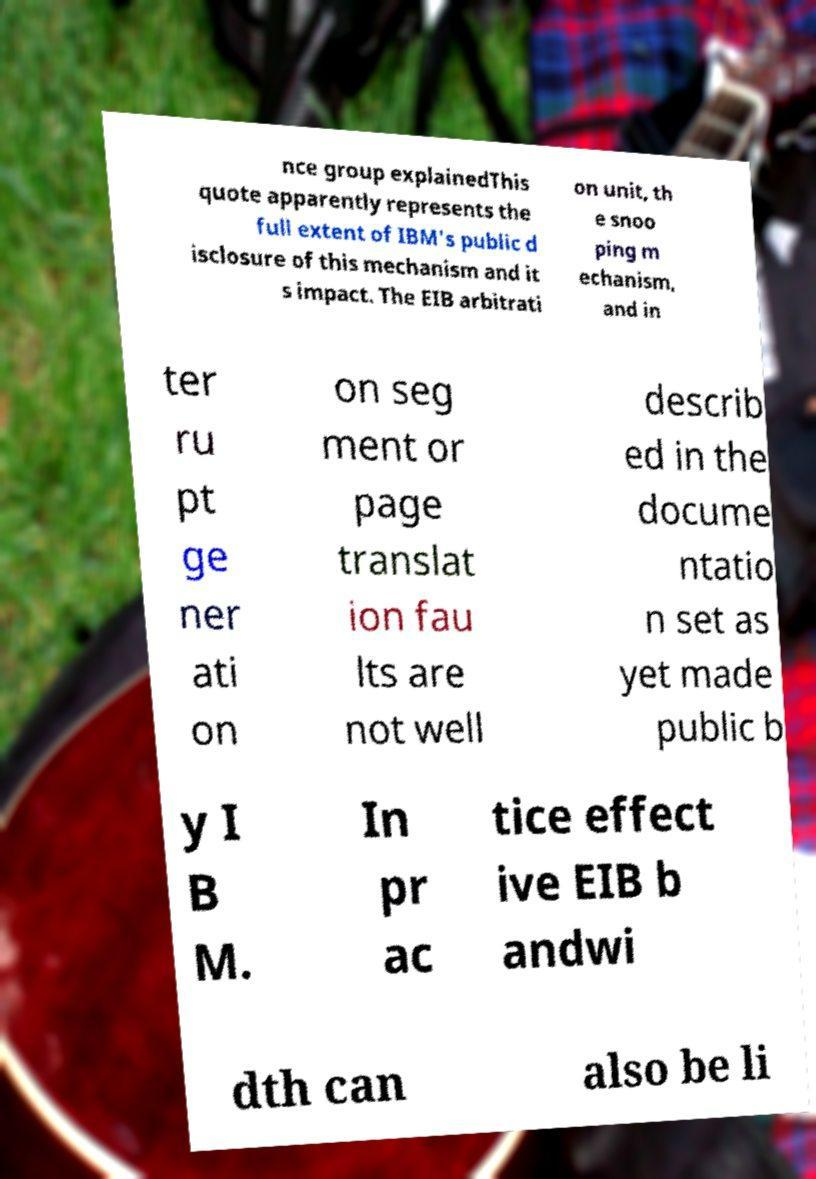Please identify and transcribe the text found in this image. nce group explainedThis quote apparently represents the full extent of IBM's public d isclosure of this mechanism and it s impact. The EIB arbitrati on unit, th e snoo ping m echanism, and in ter ru pt ge ner ati on on seg ment or page translat ion fau lts are not well describ ed in the docume ntatio n set as yet made public b y I B M. In pr ac tice effect ive EIB b andwi dth can also be li 